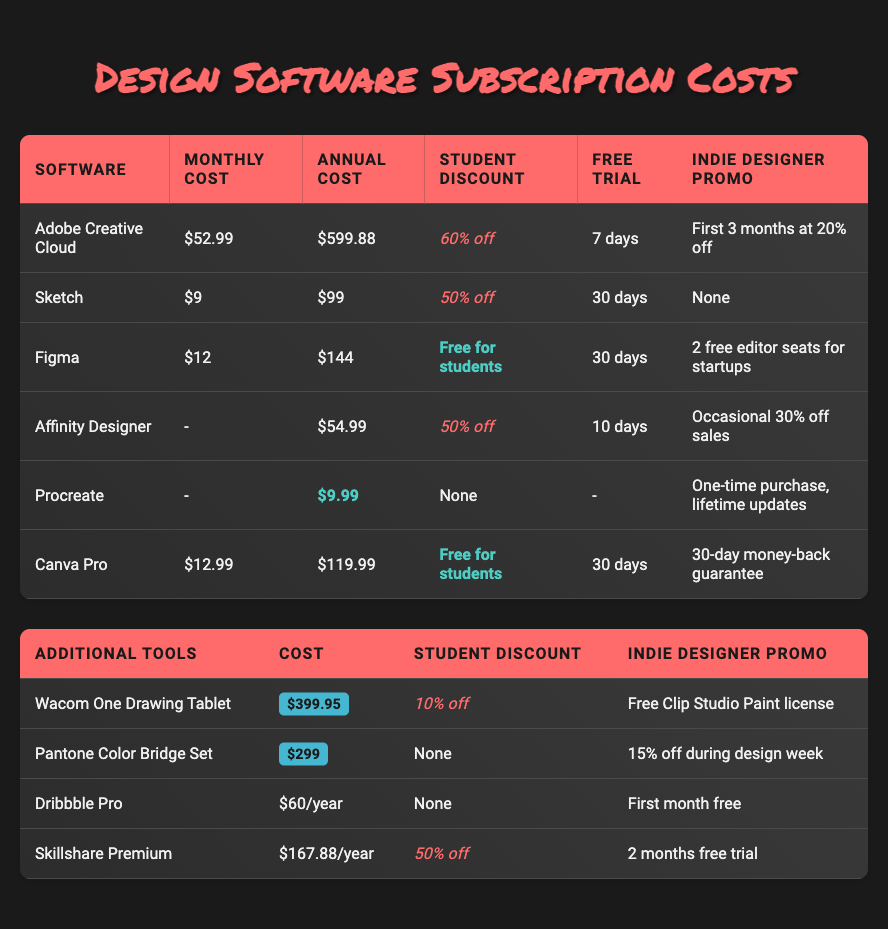What is the monthly cost of Adobe Creative Cloud? The table lists the monthly cost for Adobe Creative Cloud as $52.99 under the column labeled "Monthly Cost."
Answer: $52.99 Which software has the longest free trial period? The table shows free trial periods for various software. Sketch and Figma have 30 days, while Adobe Creative Cloud has 7 days, Affinity Designer has 10 days, Procreate has no trial, and Canva Pro has 30 days. Therefore, Sketch and Figma both have the longest duration.
Answer: Sketch and Figma Is there a design tool that offers a lifetime license? The table indicates that Procreate is a one-time purchase offering lifetime updates, while other tools have subscription models.
Answer: Yes What is the total annual cost of Adobe Creative Cloud and Sketch? To find the total annual cost, we add the annual costs of Adobe Creative Cloud ($599.88) and Sketch ($99). Therefore, the calculation is $599.88 + $99 = $698.88.
Answer: $698.88 How much is the student discount for Figma? Figma offers a student discount labeled as "Free for students," which means students do not need to pay for the subscription.
Answer: Free What percentage discount does Adobe Creative Cloud offer for students compared to its regular price? To calculate the discount percentage, we find the original annual cost ($599.88) and apply the 60% discount: 60% of $599.88 is $359.93, making the discounted price $239.95. The calculation signifies a significant reduction from the original cost.
Answer: 60% Which software provides the highest monthly cost among the listed options? The monthly costs listed show Adobe Creative Cloud as $52.99, which is the highest compared to all other software. Sketch is $9, Figma is $12, and others have no monthly pricing.
Answer: Adobe Creative Cloud Is there any design software that has no student discount? Looking at the table, Procreate and Pantone Color Bridge Set do not offer any student discounts, so they qualify for this question.
Answer: Yes, Procreate and Pantone Color Bridge Set What is the average annual cost of the listed software subscriptions? We calculate the average annual cost by summing the annual costs of Adobe Creative Cloud ($599.88), Sketch ($99), Figma ($144), Affinity Designer ($54.99), Procreate ($9.99), and Canva Pro ($119.99). The sum is $1,028.84, and there are 6 software, so the average is $1,028.84 / 6 = $171.47.
Answer: $171.47 